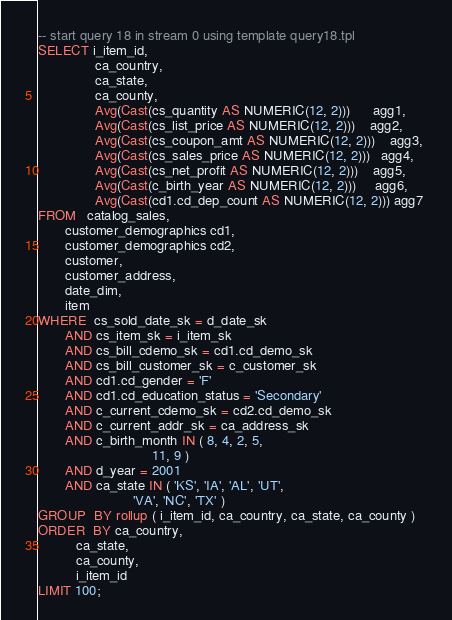<code> <loc_0><loc_0><loc_500><loc_500><_SQL_>-- start query 18 in stream 0 using template query18.tpl 
SELECT i_item_id, 
               ca_country, 
               ca_state, 
               ca_county, 
               Avg(Cast(cs_quantity AS NUMERIC(12, 2)))      agg1, 
               Avg(Cast(cs_list_price AS NUMERIC(12, 2)))    agg2, 
               Avg(Cast(cs_coupon_amt AS NUMERIC(12, 2)))    agg3, 
               Avg(Cast(cs_sales_price AS NUMERIC(12, 2)))   agg4, 
               Avg(Cast(cs_net_profit AS NUMERIC(12, 2)))    agg5, 
               Avg(Cast(c_birth_year AS NUMERIC(12, 2)))     agg6, 
               Avg(Cast(cd1.cd_dep_count AS NUMERIC(12, 2))) agg7 
FROM   catalog_sales, 
       customer_demographics cd1, 
       customer_demographics cd2, 
       customer, 
       customer_address, 
       date_dim, 
       item 
WHERE  cs_sold_date_sk = d_date_sk 
       AND cs_item_sk = i_item_sk 
       AND cs_bill_cdemo_sk = cd1.cd_demo_sk 
       AND cs_bill_customer_sk = c_customer_sk 
       AND cd1.cd_gender = 'F' 
       AND cd1.cd_education_status = 'Secondary' 
       AND c_current_cdemo_sk = cd2.cd_demo_sk 
       AND c_current_addr_sk = ca_address_sk 
       AND c_birth_month IN ( 8, 4, 2, 5, 
                              11, 9 ) 
       AND d_year = 2001 
       AND ca_state IN ( 'KS', 'IA', 'AL', 'UT', 
                         'VA', 'NC', 'TX' ) 
GROUP  BY rollup ( i_item_id, ca_country, ca_state, ca_county ) 
ORDER  BY ca_country, 
          ca_state, 
          ca_county, 
          i_item_id
LIMIT 100; 
</code> 